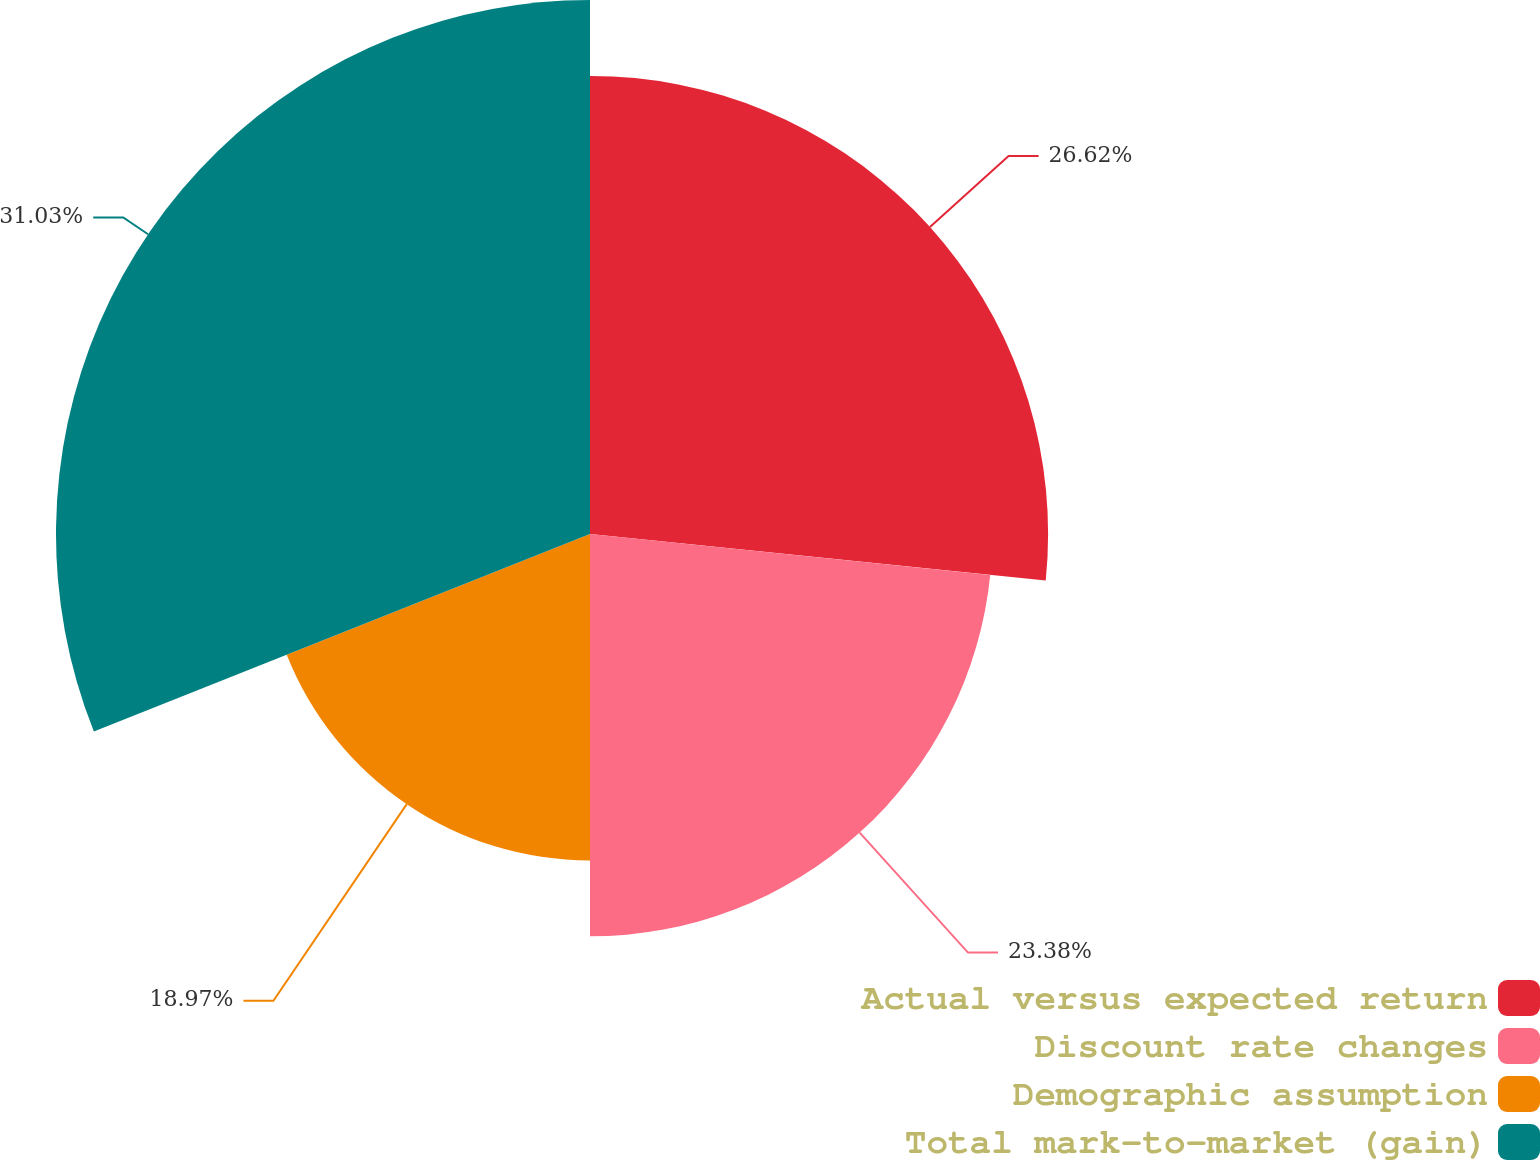Convert chart. <chart><loc_0><loc_0><loc_500><loc_500><pie_chart><fcel>Actual versus expected return<fcel>Discount rate changes<fcel>Demographic assumption<fcel>Total mark-to-market (gain)<nl><fcel>26.62%<fcel>23.38%<fcel>18.97%<fcel>31.03%<nl></chart> 